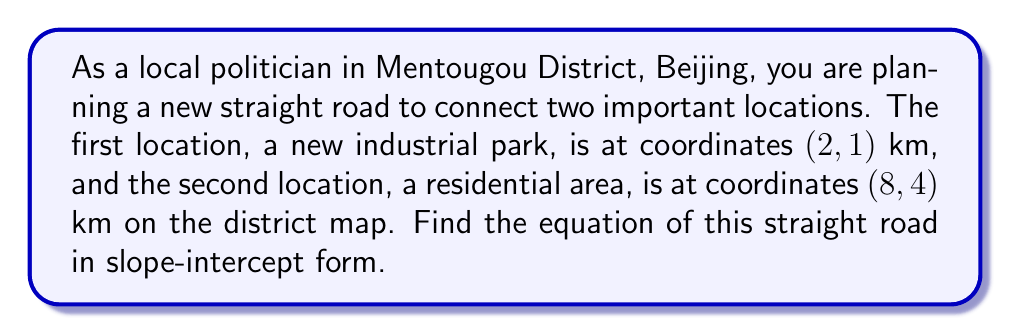Solve this math problem. To find the equation of the straight road, we'll use the point-slope form and then convert it to slope-intercept form. Let's follow these steps:

1. Calculate the slope of the line:
   The slope formula is $m = \frac{y_2 - y_1}{x_2 - x_1}$
   
   $$m = \frac{4 - 1}{8 - 2} = \frac{3}{6} = \frac{1}{2}$$

2. Use the point-slope form of a line:
   $y - y_1 = m(x - x_1)$
   
   Let's use the first point (2, 1):
   
   $$y - 1 = \frac{1}{2}(x - 2)$$

3. Expand the equation:
   $$y - 1 = \frac{1}{2}x - 1$$

4. Add 1 to both sides to isolate y:
   $$y = \frac{1}{2}x - 1 + 1$$

5. Simplify to get the slope-intercept form $(y = mx + b)$:
   $$y = \frac{1}{2}x$$

Therefore, the equation of the straight road in slope-intercept form is $y = \frac{1}{2}x$.

To verify, we can check if both points satisfy this equation:
For (2, 1): $1 = \frac{1}{2}(2)$, which is true.
For (8, 4): $4 = \frac{1}{2}(8)$, which is also true.
Answer: $y = \frac{1}{2}x$ 